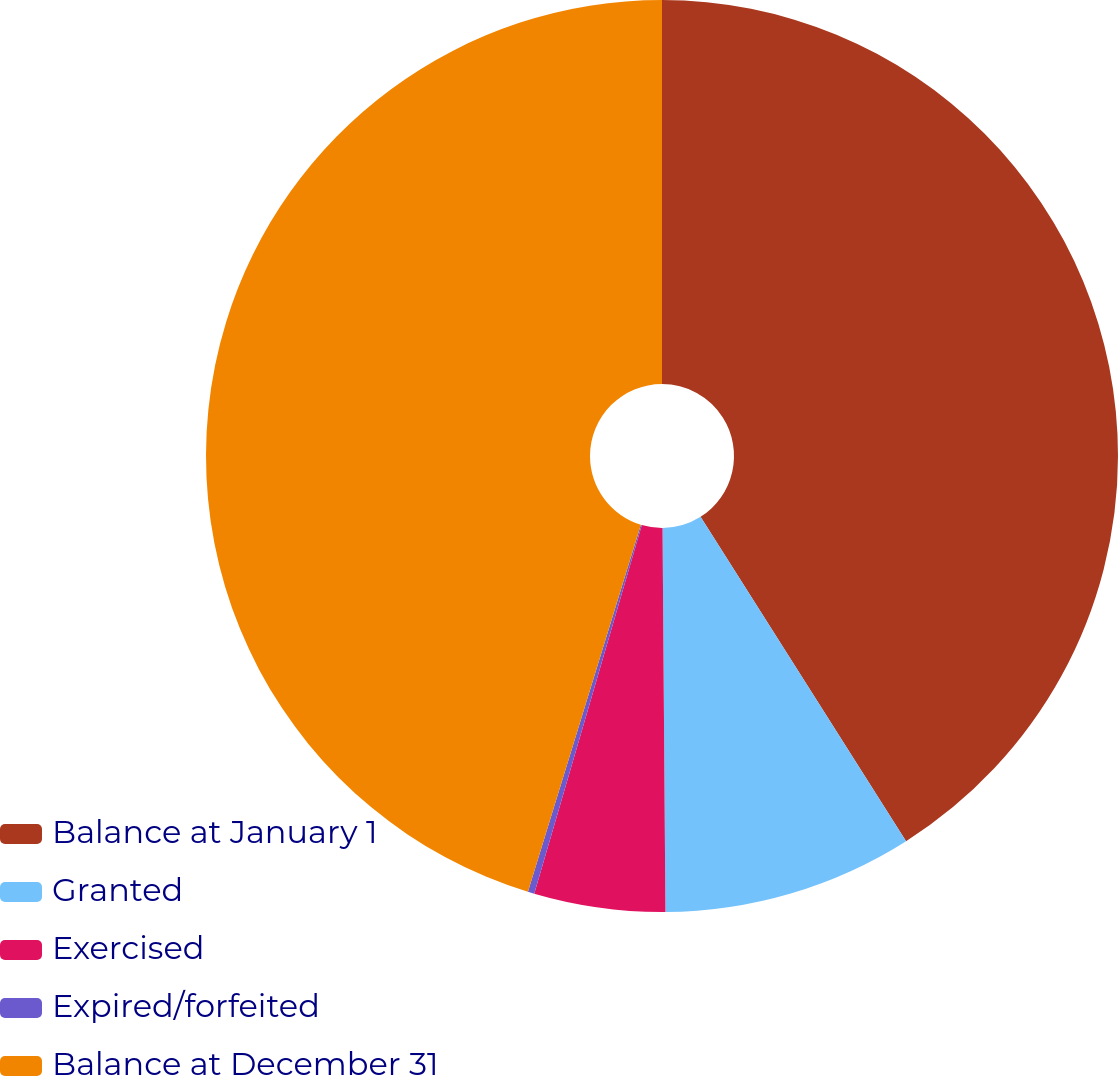Convert chart to OTSL. <chart><loc_0><loc_0><loc_500><loc_500><pie_chart><fcel>Balance at January 1<fcel>Granted<fcel>Exercised<fcel>Expired/forfeited<fcel>Balance at December 31<nl><fcel>41.01%<fcel>8.87%<fcel>4.64%<fcel>0.23%<fcel>45.25%<nl></chart> 